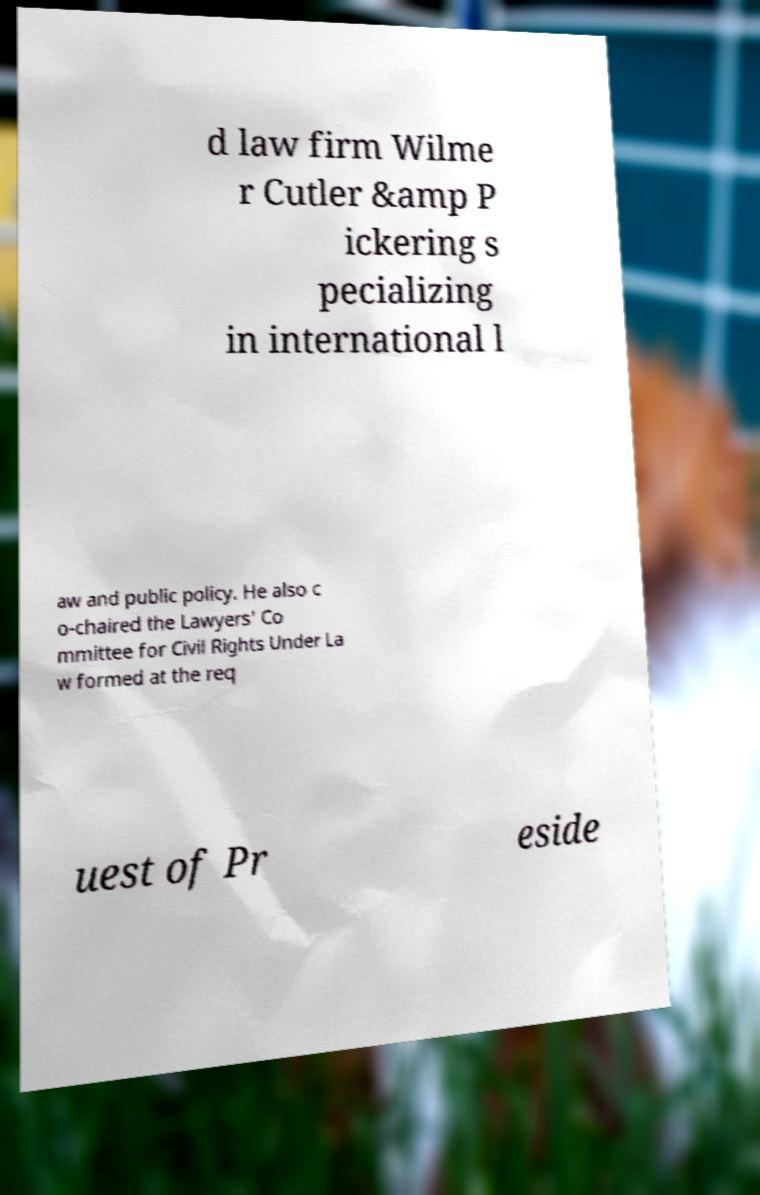Please read and relay the text visible in this image. What does it say? d law firm Wilme r Cutler &amp P ickering s pecializing in international l aw and public policy. He also c o-chaired the Lawyers' Co mmittee for Civil Rights Under La w formed at the req uest of Pr eside 